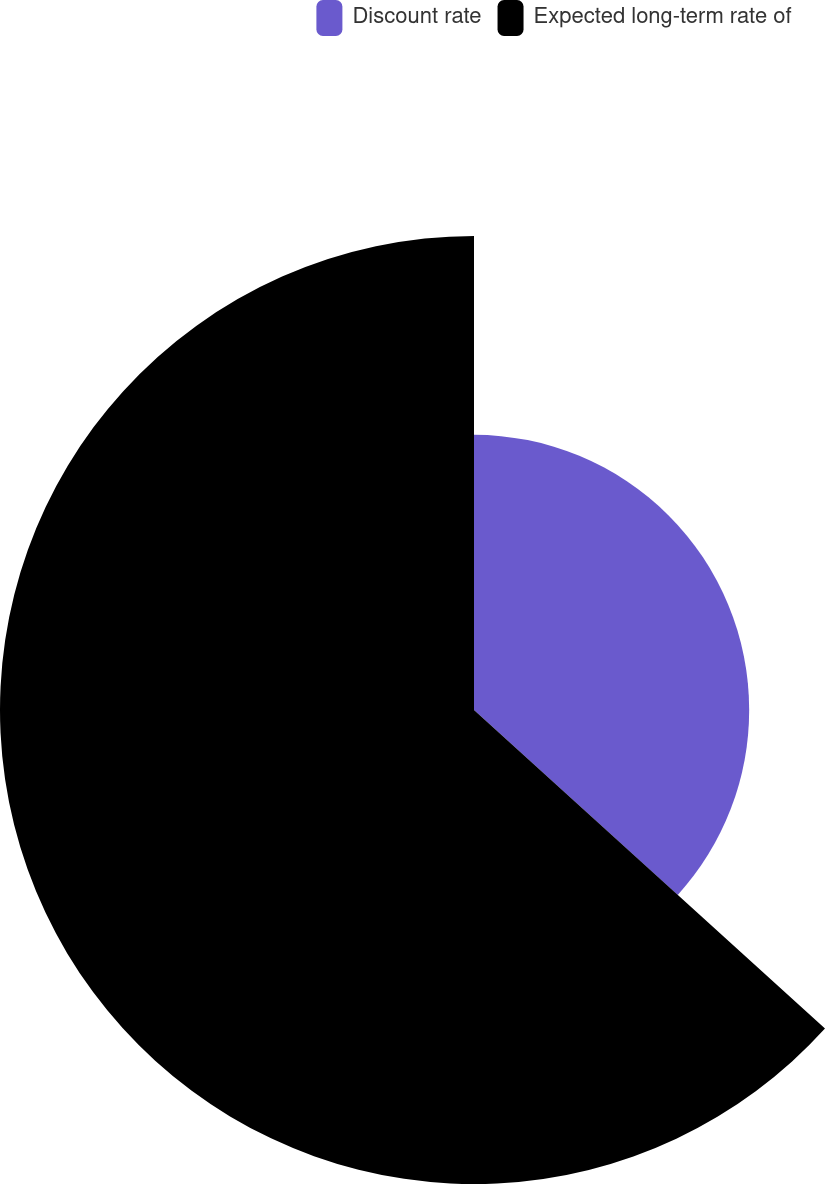<chart> <loc_0><loc_0><loc_500><loc_500><pie_chart><fcel>Discount rate<fcel>Expected long-term rate of<nl><fcel>36.73%<fcel>63.27%<nl></chart> 